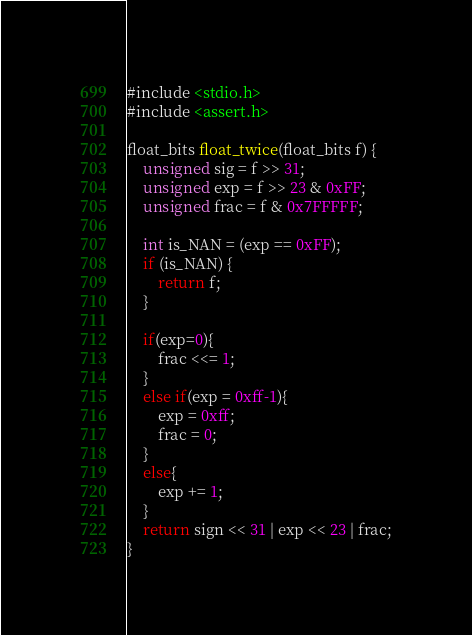Convert code to text. <code><loc_0><loc_0><loc_500><loc_500><_C_>#include <stdio.h>
#include <assert.h>

float_bits float_twice(float_bits f) {
    unsigned sig = f >> 31;
    unsigned exp = f >> 23 & 0xFF;
    unsigned frac = f & 0x7FFFFF;

    int is_NAN = (exp == 0xFF); 
    if (is_NAN) {
        return f;
    }

    if(exp=0){
        frac <<= 1;
    }
    else if(exp = 0xff-1){
        exp = 0xff;
        frac = 0;
    }
    else{
        exp += 1;
    }
    return sign << 31 | exp << 23 | frac;
}
</code> 